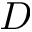<formula> <loc_0><loc_0><loc_500><loc_500>D</formula> 